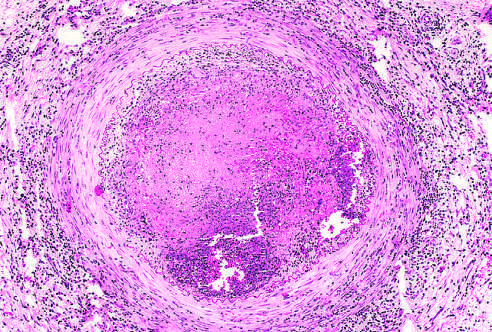what is the vessel wall infiltrated with?
Answer the question using a single word or phrase. Leukocytes 